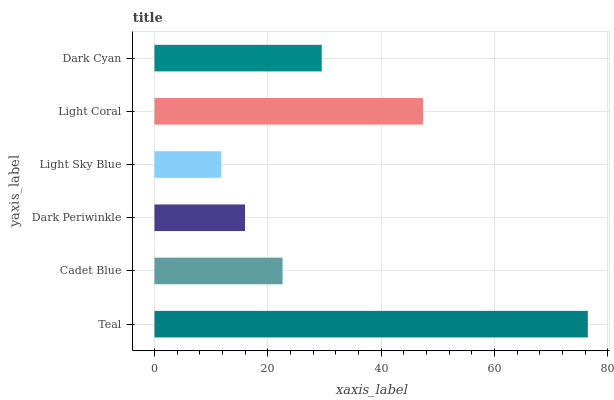Is Light Sky Blue the minimum?
Answer yes or no. Yes. Is Teal the maximum?
Answer yes or no. Yes. Is Cadet Blue the minimum?
Answer yes or no. No. Is Cadet Blue the maximum?
Answer yes or no. No. Is Teal greater than Cadet Blue?
Answer yes or no. Yes. Is Cadet Blue less than Teal?
Answer yes or no. Yes. Is Cadet Blue greater than Teal?
Answer yes or no. No. Is Teal less than Cadet Blue?
Answer yes or no. No. Is Dark Cyan the high median?
Answer yes or no. Yes. Is Cadet Blue the low median?
Answer yes or no. Yes. Is Dark Periwinkle the high median?
Answer yes or no. No. Is Dark Cyan the low median?
Answer yes or no. No. 